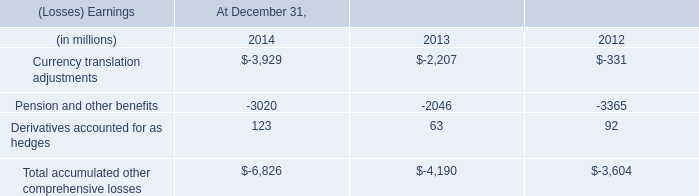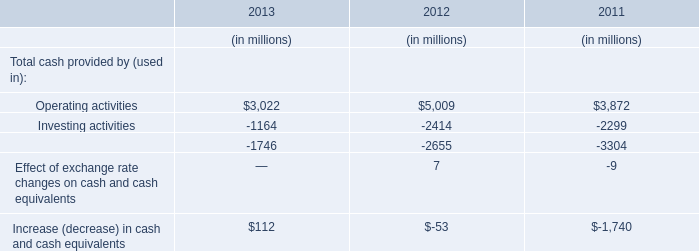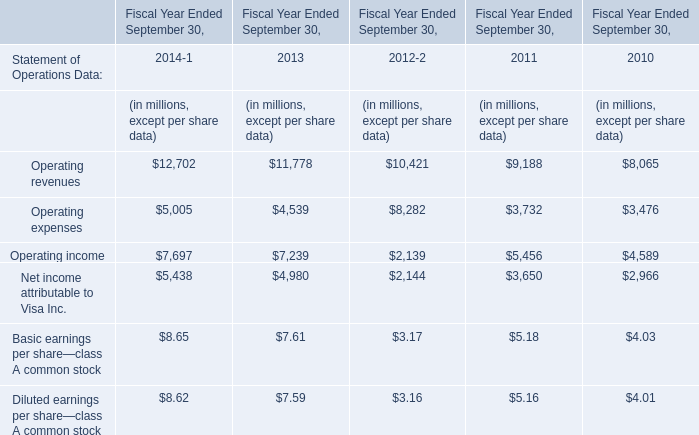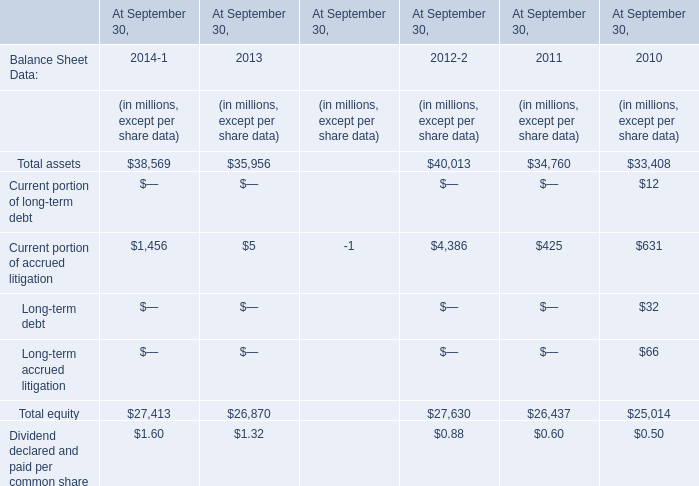As As the chart 2 shows,what's the growth rate of Operating income in Fiscal Year Ended September 30,2014? 
Computations: ((7697 - 7239) / 7239)
Answer: 0.06327. 